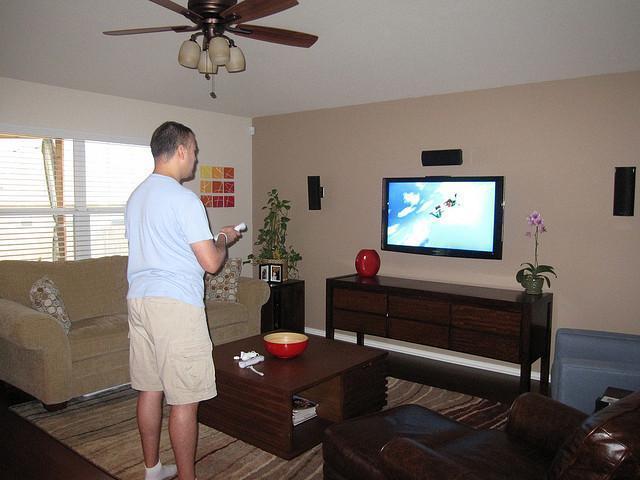How many couches are there?
Give a very brief answer. 1. 